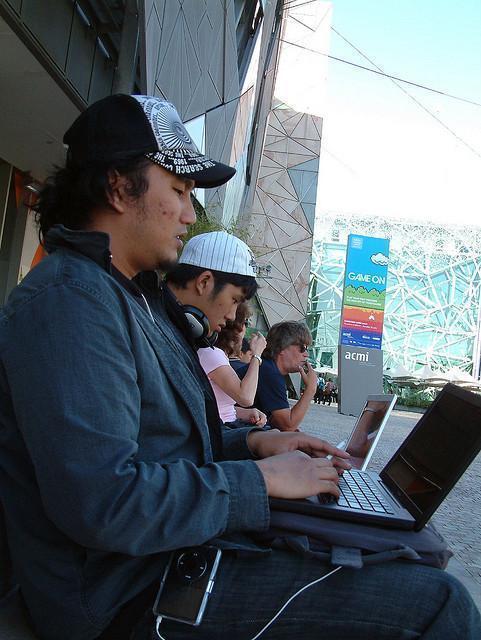What race is the man closest to the camera?
Indicate the correct choice and explain in the format: 'Answer: answer
Rationale: rationale.'
Options: Black, asian, white, indian. Answer: asian.
Rationale: This seems to be the case given the facial features. 